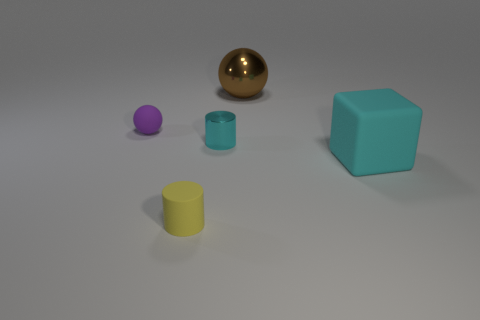Add 3 rubber things. How many objects exist? 8 Subtract all cylinders. How many objects are left? 3 Subtract 0 brown blocks. How many objects are left? 5 Subtract all big gray metal cylinders. Subtract all large balls. How many objects are left? 4 Add 1 metal spheres. How many metal spheres are left? 2 Add 1 big brown shiny objects. How many big brown shiny objects exist? 2 